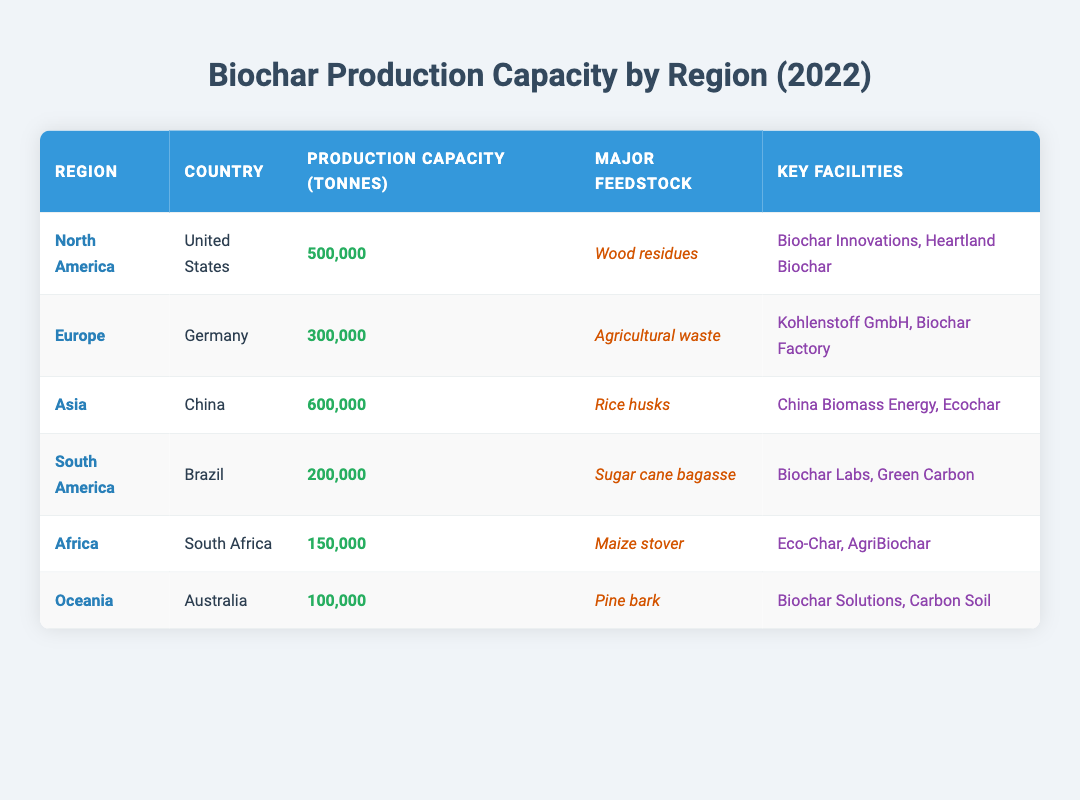What is the production capacity of biochar in North America? The table indicates that the production capacity of biochar in North America is listed under the "Production Capacity (tonnes)" column for the United States, which shows a value of 500,000 tonnes.
Answer: 500,000 tonnes Which country has the highest biochar production capacity? By examining the "Production Capacity (tonnes)" column, the highest value is found for China, which has a production capacity of 600,000 tonnes.
Answer: China What are the major feedstocks for biochar production in Europe? In the table, the entry for Europe specifically lists Germany under the "Country" column and identifies "Agricultural waste" in the "Major Feedstock" column.
Answer: Agricultural waste What is the total biochar production capacity for South America and Africa combined? To find the total, we sum the production capacities of Brazil (200,000 tonnes) and South Africa (150,000 tonnes). Calculation: 200,000 + 150,000 = 350,000 tonnes.
Answer: 350,000 tonnes Is Australia the region with the lowest biochar production capacity? Looking at the "Production Capacity (tonnes)" column, Australia has a capacity of 100,000 tonnes, which is indeed lower than all other entries in the table, confirming that it is the lowest.
Answer: Yes Which feedstock is used for biochar production in China? The table shows that under China's entry in the "Major Feedstock" column, "Rice husks" is listed as the feedstock used for biochar production.
Answer: Rice husks How many key facilities are identified for biochar production in North America? The table for North America lists two key facilities under the "Key Facilities" column: "Biochar Innovations" and "Heartland Biochar," indicating there are two.
Answer: 2 What is the production capacity difference between Asia and Oceania? The production capacity for Asia (600,000 tonnes) minus Oceania (100,000 tonnes) gives the difference. Calculation: 600,000 - 100,000 = 500,000 tonnes difference in capacity.
Answer: 500,000 tonnes What are the key facilities for biochar production in South Africa? The entry for South Africa lists "Eco-Char" and "AgriBiochar" in the "Key Facilities" column as the facilities relevant to biochar production there.
Answer: Eco-Char, AgriBiochar 